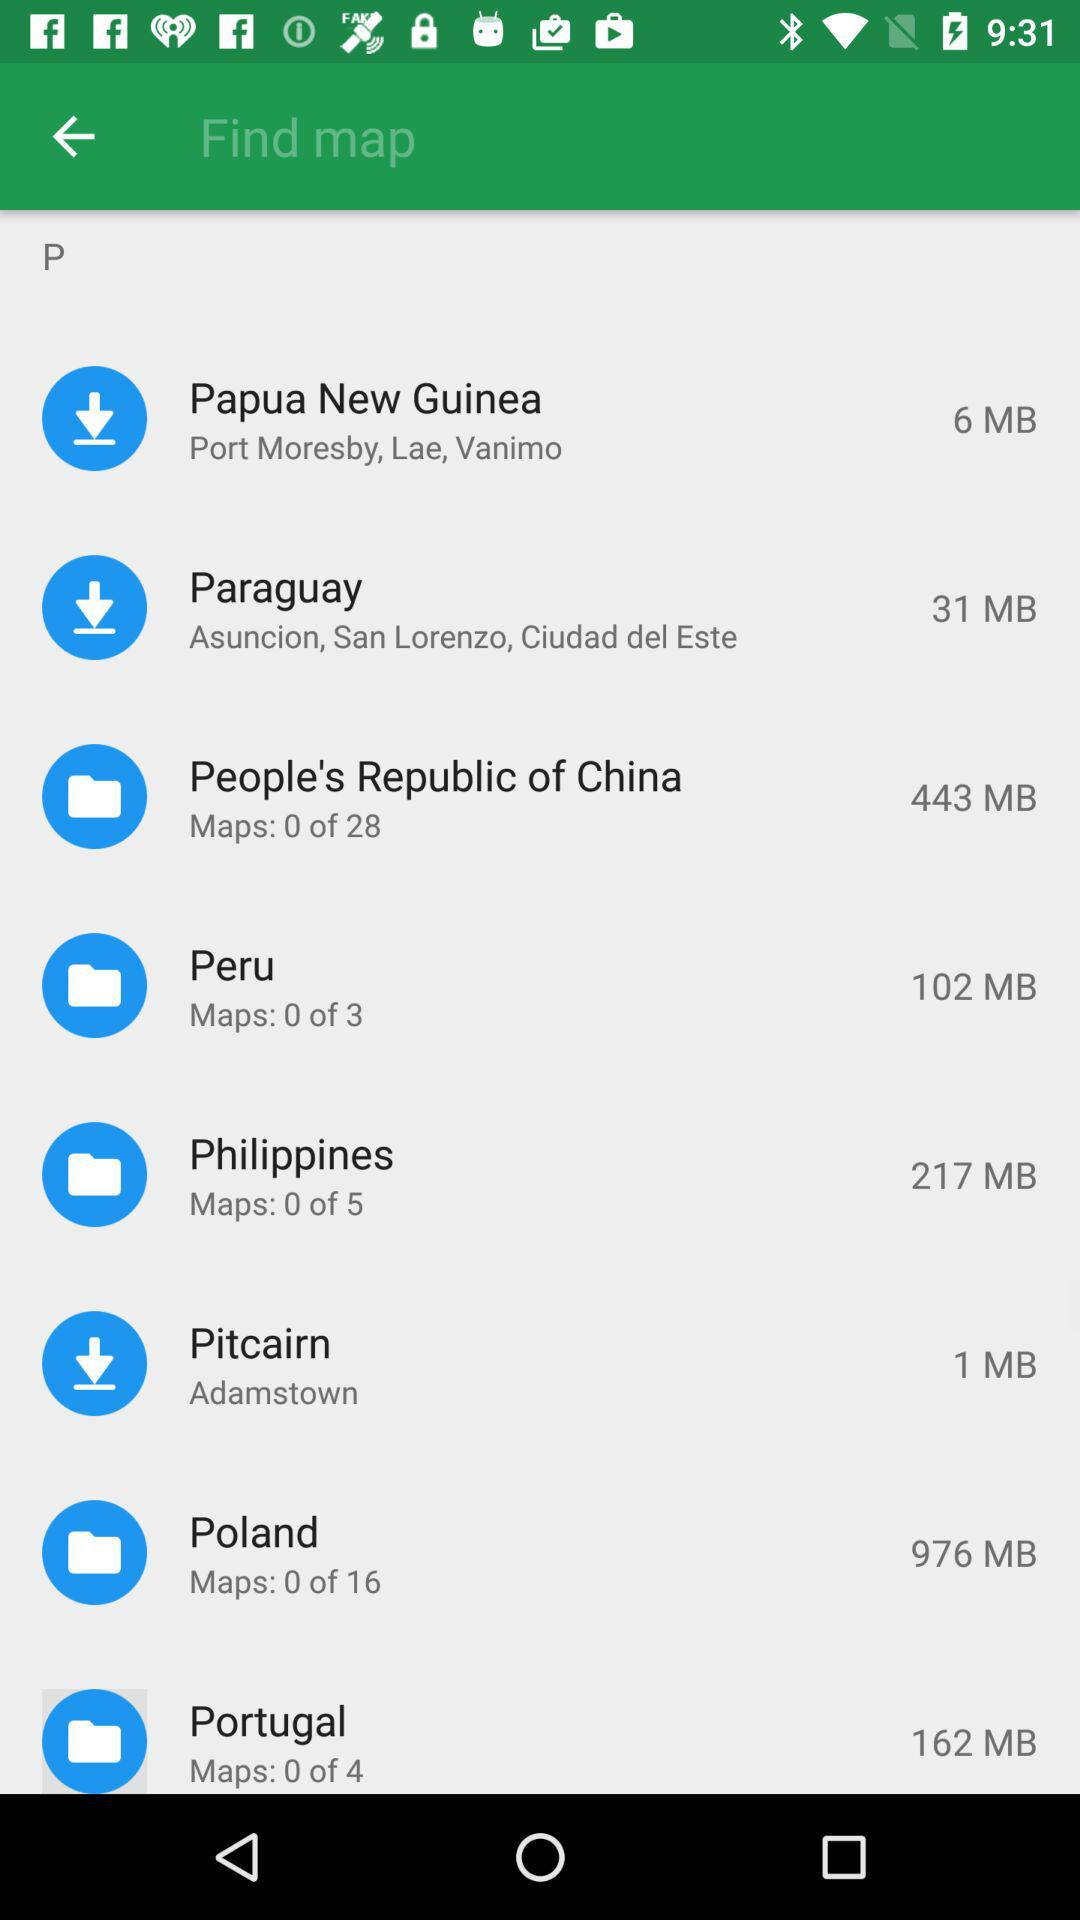How much more data is required to download the Philippines map than the Pitcairn map?
Answer the question using a single word or phrase. 216 MB 